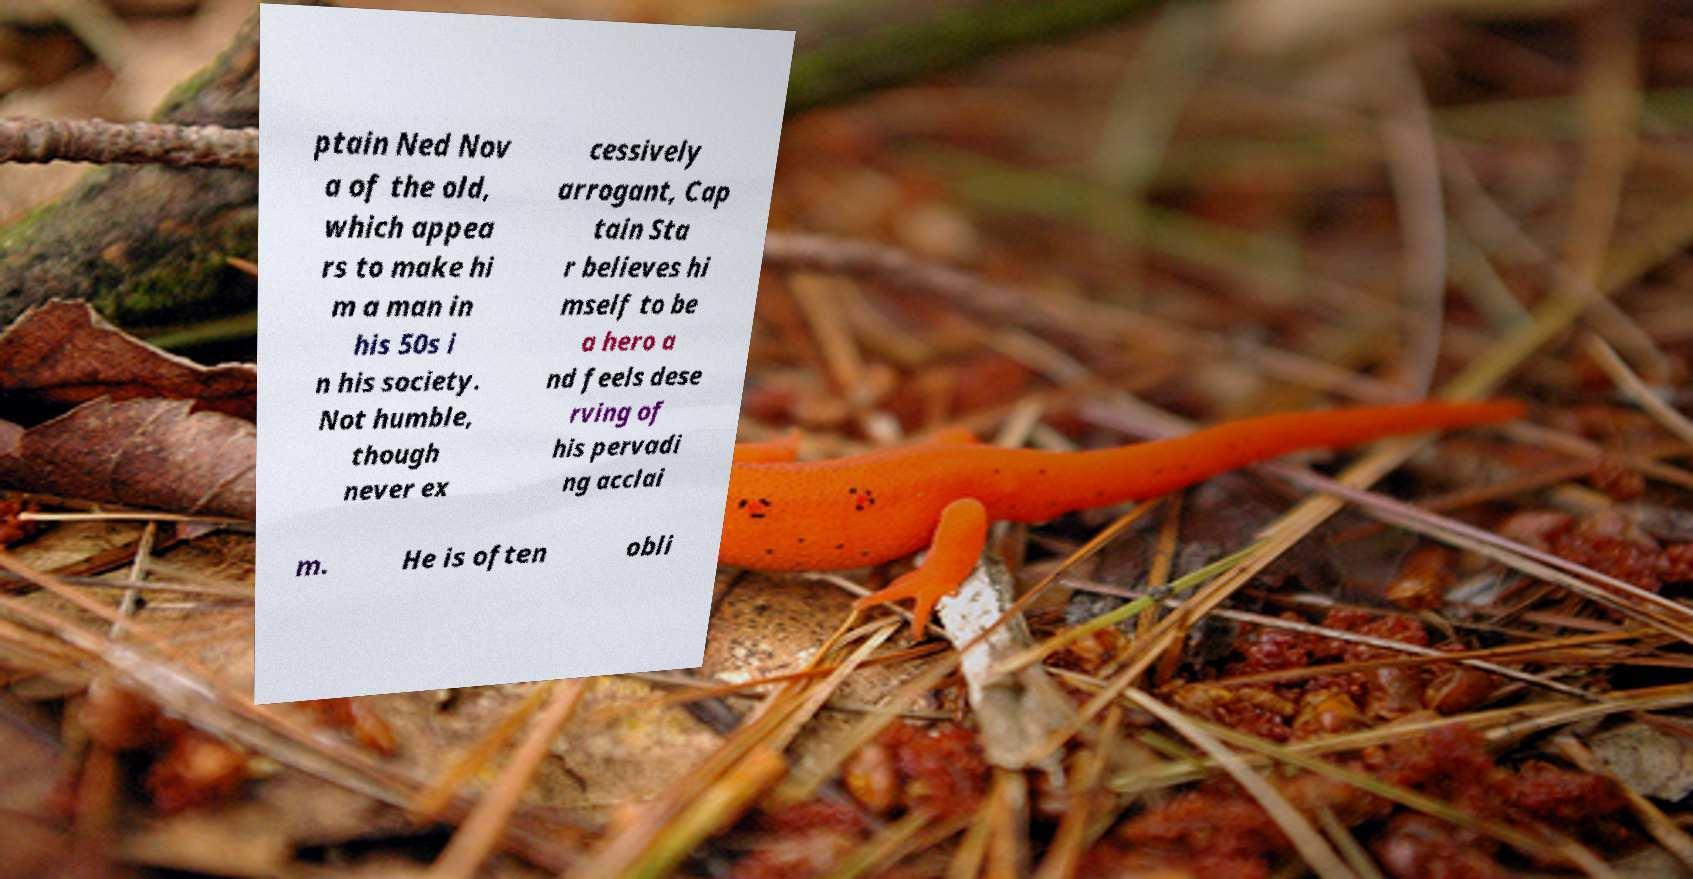Please identify and transcribe the text found in this image. ptain Ned Nov a of the old, which appea rs to make hi m a man in his 50s i n his society. Not humble, though never ex cessively arrogant, Cap tain Sta r believes hi mself to be a hero a nd feels dese rving of his pervadi ng acclai m. He is often obli 